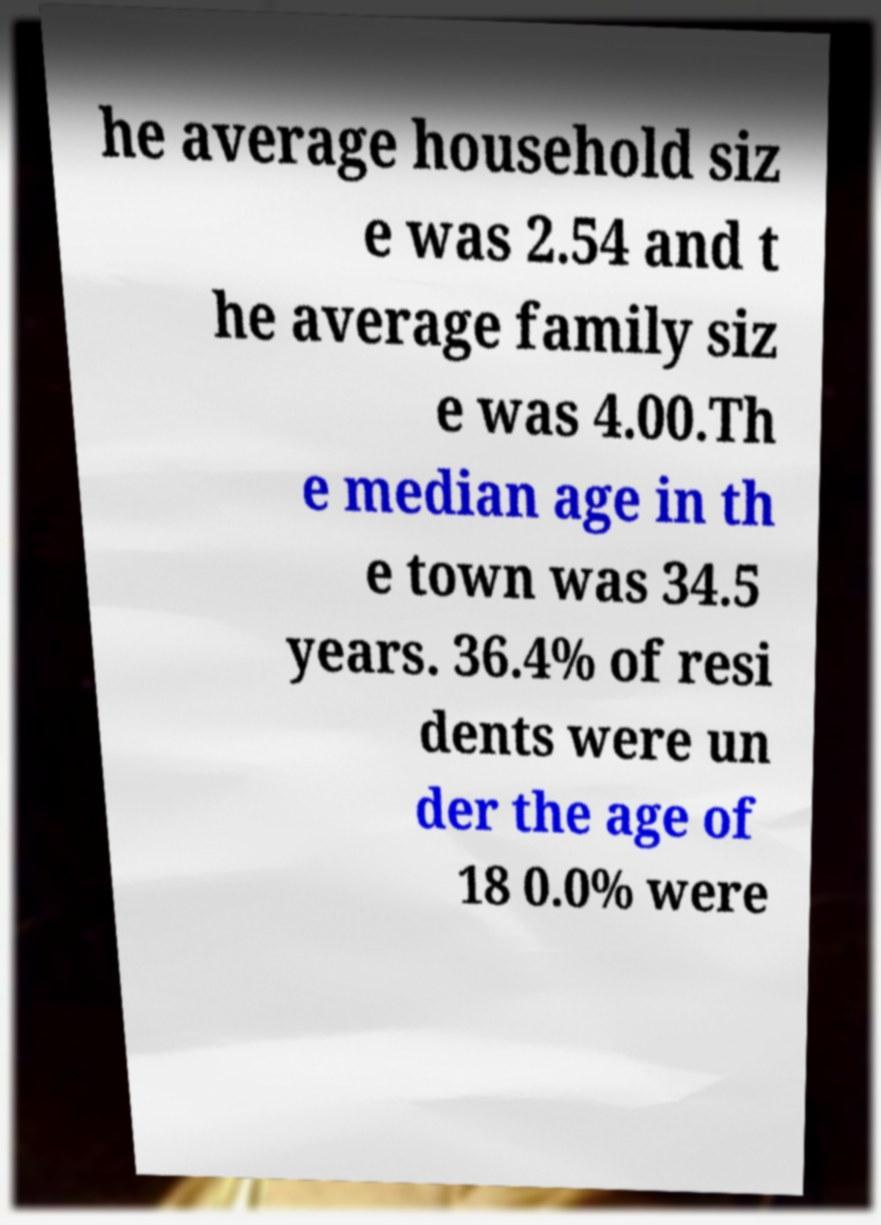Can you read and provide the text displayed in the image?This photo seems to have some interesting text. Can you extract and type it out for me? he average household siz e was 2.54 and t he average family siz e was 4.00.Th e median age in th e town was 34.5 years. 36.4% of resi dents were un der the age of 18 0.0% were 